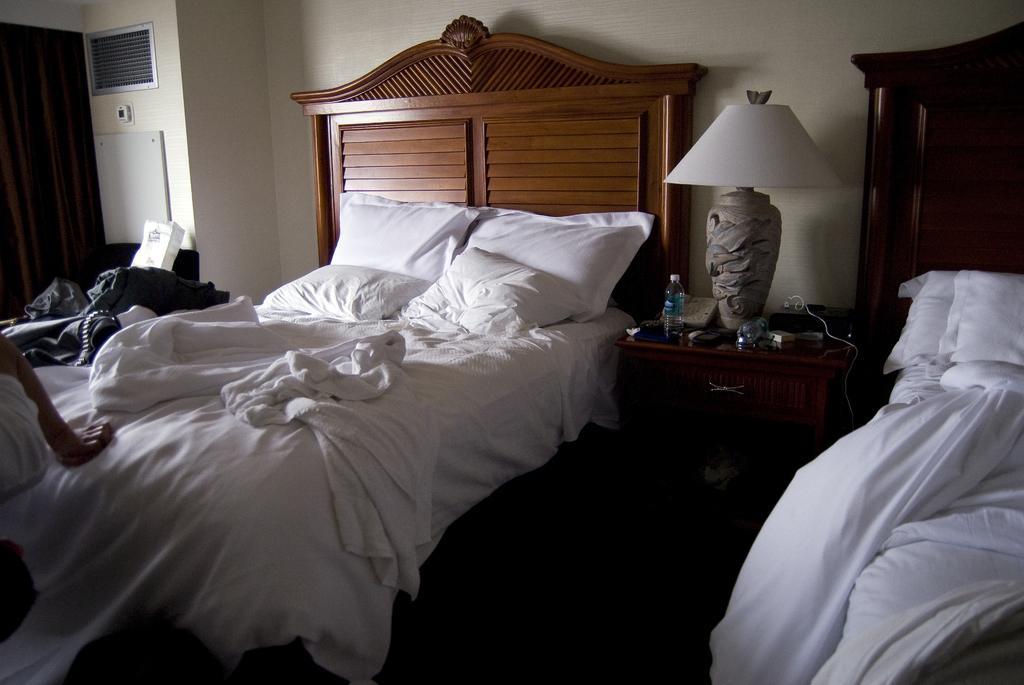Can you describe this image briefly? In this picture we can see a room with bed and on bed we have bed sheet, pillows and aside to this beds there is table and on table we can see bottle, lamp, book, wires and in background we can see wall. 